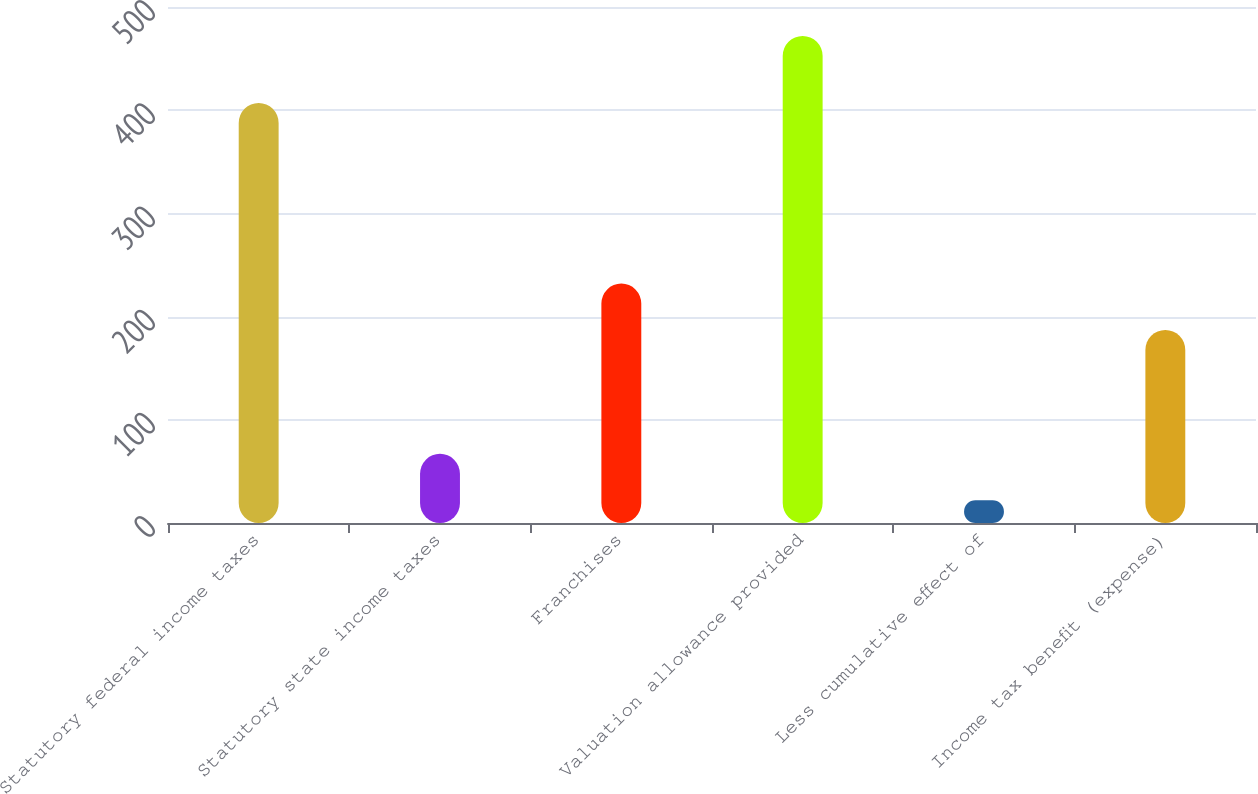Convert chart. <chart><loc_0><loc_0><loc_500><loc_500><bar_chart><fcel>Statutory federal income taxes<fcel>Statutory state income taxes<fcel>Franchises<fcel>Valuation allowance provided<fcel>Less cumulative effect of<fcel>Income tax benefit (expense)<nl><fcel>407<fcel>67<fcel>232<fcel>472<fcel>22<fcel>187<nl></chart> 